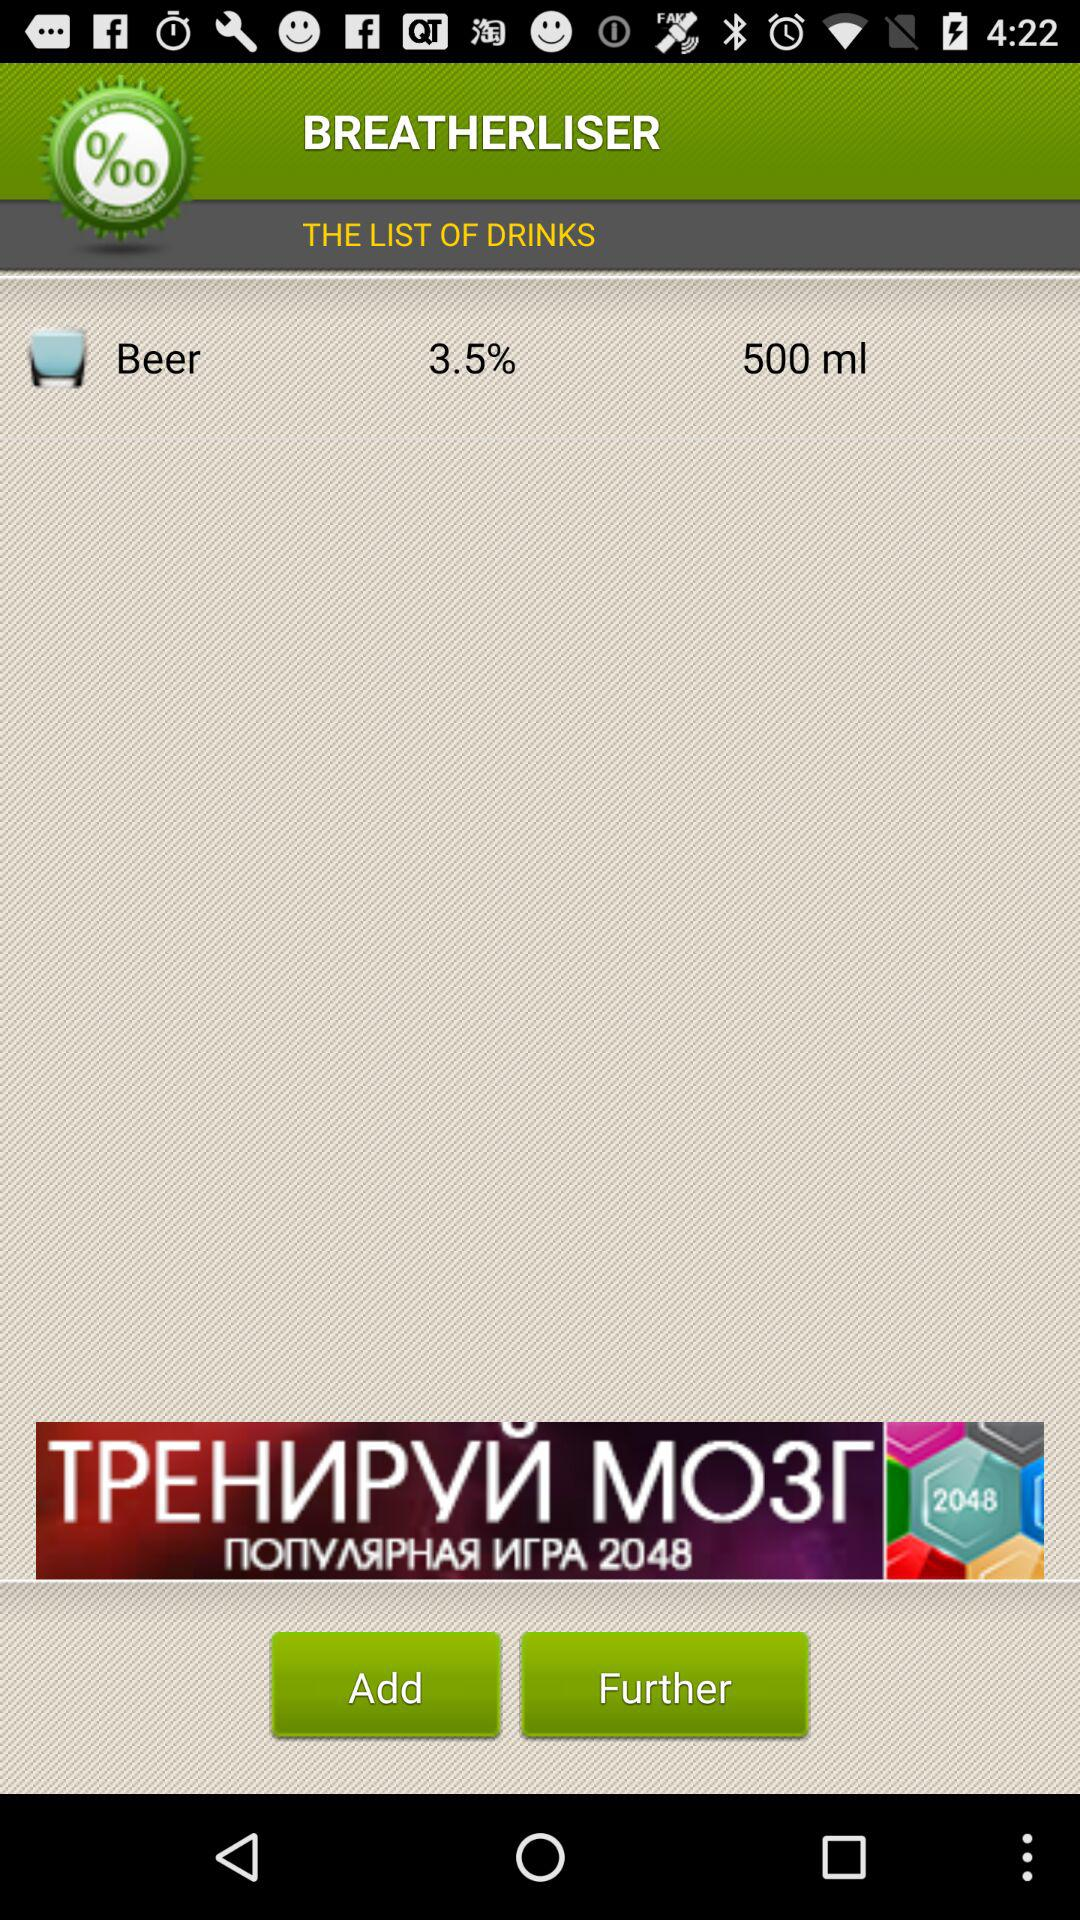What is the mentioned percentage? The mentioned percentage is 3.5. 